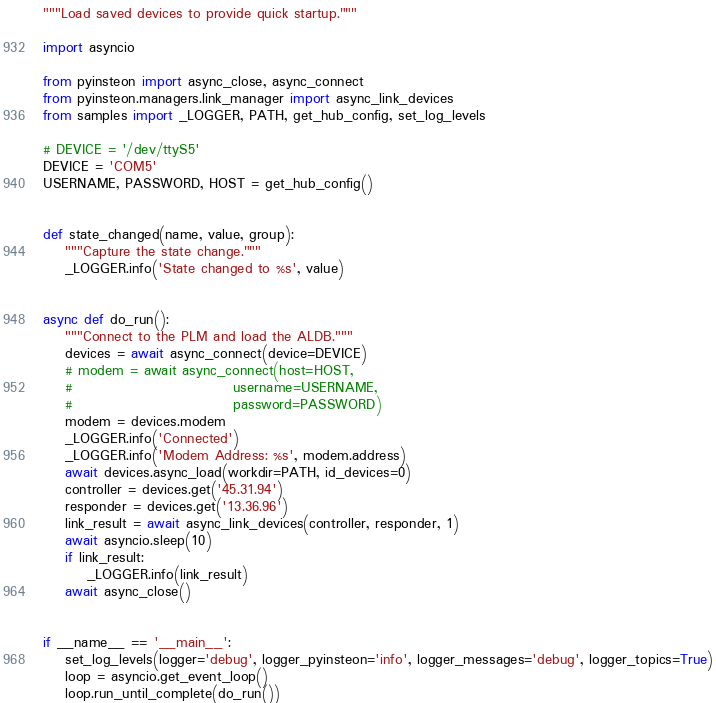<code> <loc_0><loc_0><loc_500><loc_500><_Python_>"""Load saved devices to provide quick startup."""

import asyncio

from pyinsteon import async_close, async_connect
from pyinsteon.managers.link_manager import async_link_devices
from samples import _LOGGER, PATH, get_hub_config, set_log_levels

# DEVICE = '/dev/ttyS5'
DEVICE = 'COM5'
USERNAME, PASSWORD, HOST = get_hub_config()


def state_changed(name, value, group):
    """Capture the state change."""
    _LOGGER.info('State changed to %s', value)


async def do_run():
    """Connect to the PLM and load the ALDB."""
    devices = await async_connect(device=DEVICE)
    # modem = await async_connect(host=HOST,
    #                             username=USERNAME,
    #                             password=PASSWORD)
    modem = devices.modem
    _LOGGER.info('Connected')
    _LOGGER.info('Modem Address: %s', modem.address)
    await devices.async_load(workdir=PATH, id_devices=0)
    controller = devices.get('45.31.94')
    responder = devices.get('13.36.96')
    link_result = await async_link_devices(controller, responder, 1)
    await asyncio.sleep(10)
    if link_result:
        _LOGGER.info(link_result)
    await async_close()


if __name__ == '__main__':
    set_log_levels(logger='debug', logger_pyinsteon='info', logger_messages='debug', logger_topics=True)
    loop = asyncio.get_event_loop()
    loop.run_until_complete(do_run())
</code> 